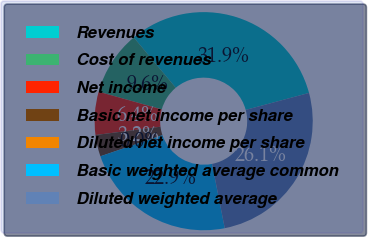<chart> <loc_0><loc_0><loc_500><loc_500><pie_chart><fcel>Revenues<fcel>Cost of revenues<fcel>Net income<fcel>Basic net income per share<fcel>Diluted net income per share<fcel>Basic weighted average common<fcel>Diluted weighted average<nl><fcel>31.9%<fcel>9.57%<fcel>6.38%<fcel>3.19%<fcel>0.0%<fcel>22.88%<fcel>26.07%<nl></chart> 